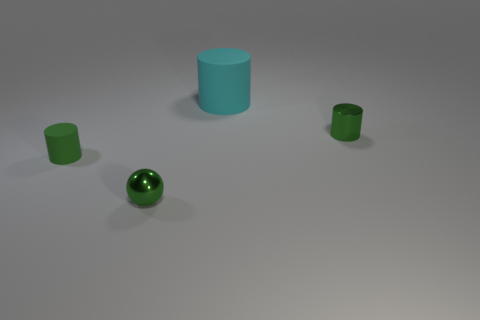What number of green objects are either large rubber cylinders or balls?
Make the answer very short. 1. Are there any green objects of the same size as the green metallic cylinder?
Offer a terse response. Yes. The green thing that is in front of the green cylinder on the left side of the small thing that is on the right side of the cyan cylinder is made of what material?
Offer a very short reply. Metal. Is the number of tiny green rubber cylinders that are right of the tiny green ball the same as the number of big cyan cylinders?
Provide a short and direct response. No. Are the green cylinder that is to the right of the tiny ball and the small object in front of the green matte object made of the same material?
Offer a very short reply. Yes. What number of things are either small objects or green cylinders right of the big rubber thing?
Your answer should be compact. 3. Are there any tiny green things of the same shape as the big cyan object?
Give a very brief answer. Yes. There is a rubber thing that is right of the metal thing that is to the left of the green object on the right side of the big cyan rubber cylinder; what is its size?
Offer a terse response. Large. Are there an equal number of matte things behind the green shiny cylinder and metallic spheres on the right side of the big cyan object?
Your answer should be very brief. No. What size is the green object that is made of the same material as the ball?
Offer a very short reply. Small. 